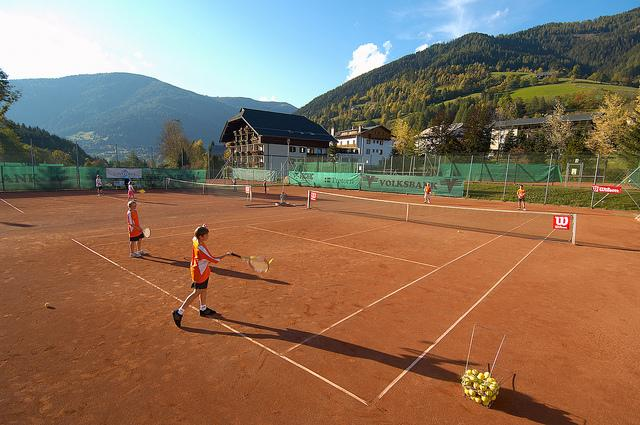What event is being carried out? tennis 